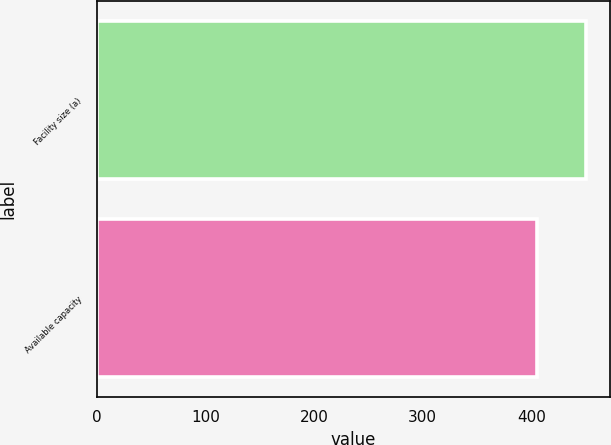<chart> <loc_0><loc_0><loc_500><loc_500><bar_chart><fcel>Facility size (a)<fcel>Available capacity<nl><fcel>450<fcel>405<nl></chart> 